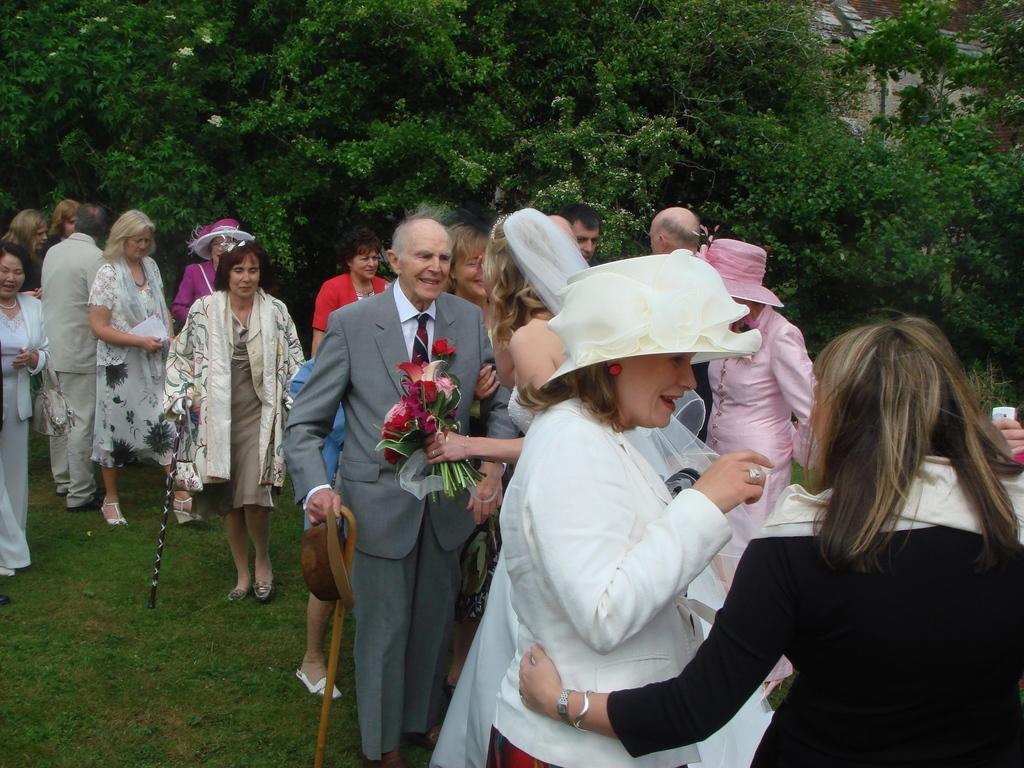What is the main subject of the image? The main subject of the image is the persons standing in the middle of the image. What can be seen in the background of the image? Trees are visible at the top of the image. What type of terrain is present at the bottom of the image? There is a grassy land at the bottom of the image. What type of dress is the giraffe wearing in the image? There is no giraffe present in the image, and therefore no dress or any clothing can be observed. 